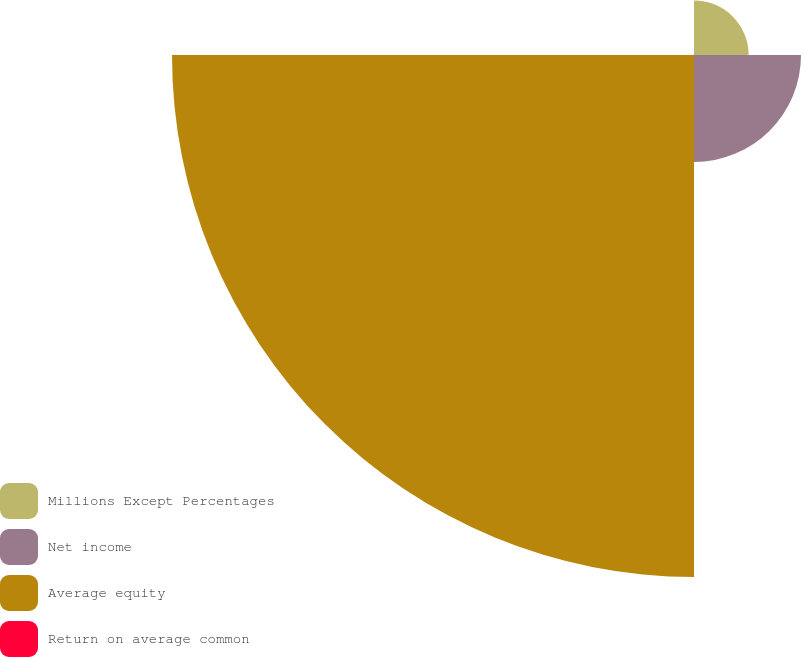Convert chart. <chart><loc_0><loc_0><loc_500><loc_500><pie_chart><fcel>Millions Except Percentages<fcel>Net income<fcel>Average equity<fcel>Return on average common<nl><fcel>7.98%<fcel>15.64%<fcel>76.29%<fcel>0.08%<nl></chart> 